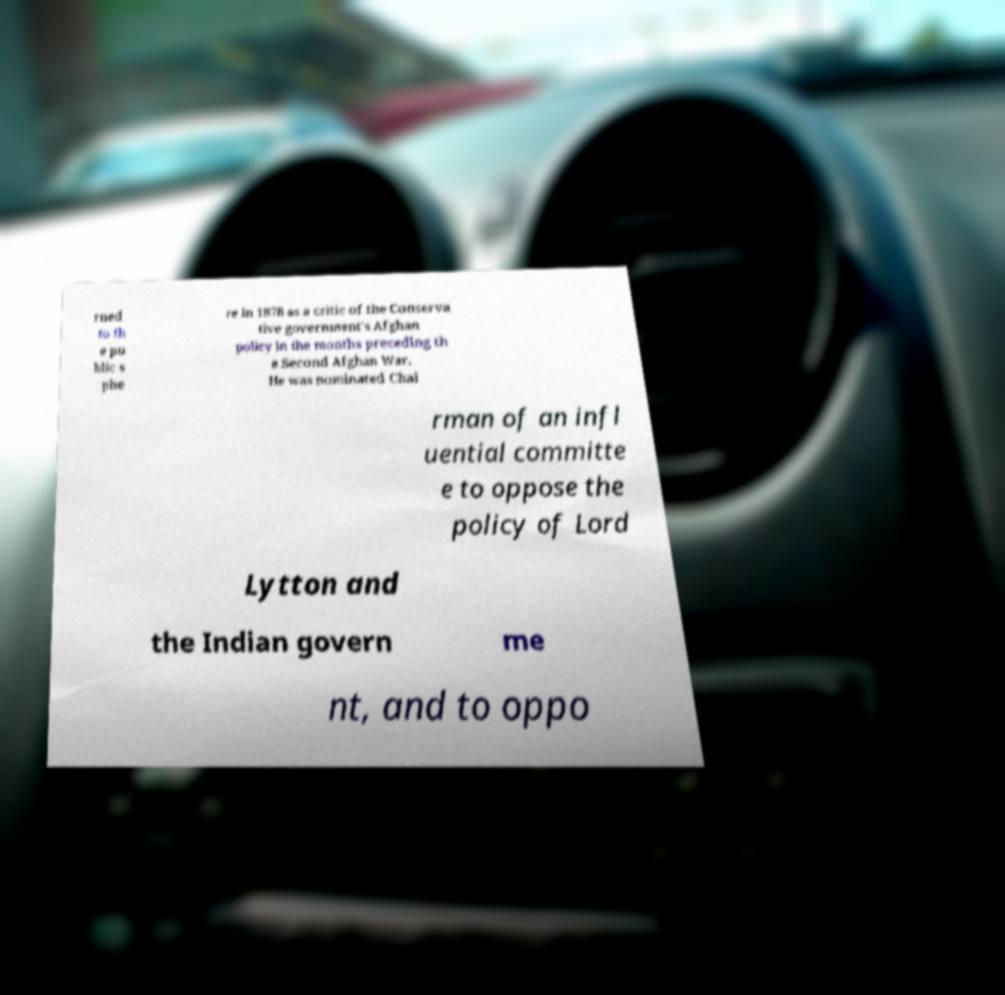Please read and relay the text visible in this image. What does it say? rned to th e pu blic s phe re in 1878 as a critic of the Conserva tive government's Afghan policy in the months preceding th e Second Afghan War. He was nominated Chai rman of an infl uential committe e to oppose the policy of Lord Lytton and the Indian govern me nt, and to oppo 